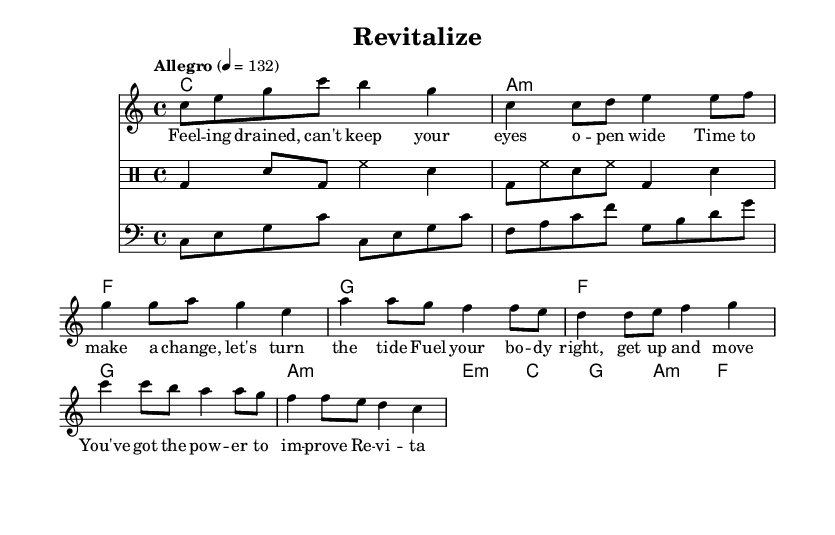What is the key signature of this music? The key signature indicated in the score is C major, which is denoted by the absence of any sharps or flats.
Answer: C major What is the time signature of the piece? The time signature shown in the music is 4/4, which means there are four beats per measure and the quarter note gets one beat.
Answer: 4/4 What is the tempo marking for this song? The tempo marking indicated in the score is "Allegro" with a metronome marking of 132, which suggests a fast and lively pace for the music.
Answer: Allegro 4 = 132 How many measures are present in the chorus section? The chorus section consists of four measures, which can be counted directly from the musical notation where the lyrics are aligned in that section.
Answer: 4 What type of lyrics are used in this song? The lyrics focus on themes of regaining energy and overcoming fatigue, as seen in phrases like "Revitalize, feel the energy flow" shown in the text section.
Answer: Overcoming fatigue What is the relationship between the melody and the chords during the chorus? During the chorus, the melody notes are aligned with the chord progression of C, G, Am, F, suggesting that each chord supports the corresponding melody for harmonic richness.
Answer: C, G, Am, F Which musical instruments are involved in this score? The score includes a lead voice for the melody, a piano or guitar for the chords, a drum staff for rhythm, and a bass line, indicating a standard band setup for dance music.
Answer: Lead, bass, drums 